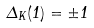Convert formula to latex. <formula><loc_0><loc_0><loc_500><loc_500>\Delta _ { K } ( 1 ) = \pm 1</formula> 